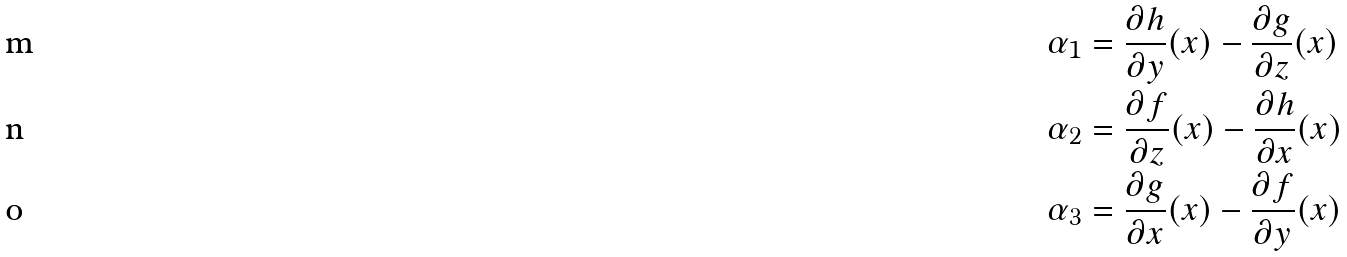<formula> <loc_0><loc_0><loc_500><loc_500>\alpha _ { 1 } & = \frac { \partial h } { \partial y } ( x ) - \frac { \partial g } { \partial z } ( x ) \\ \alpha _ { 2 } & = \frac { \partial f } { \partial z } ( x ) - \frac { \partial h } { \partial x } ( x ) \\ \alpha _ { 3 } & = \frac { \partial g } { \partial x } ( x ) - \frac { \partial f } { \partial y } ( x )</formula> 